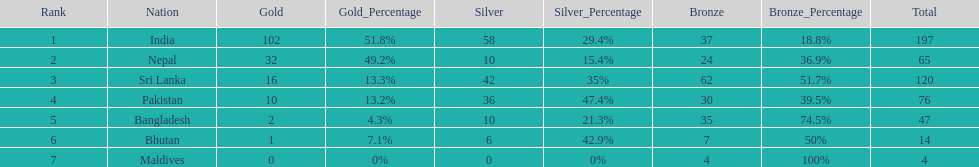Name the first country on the table? India. 